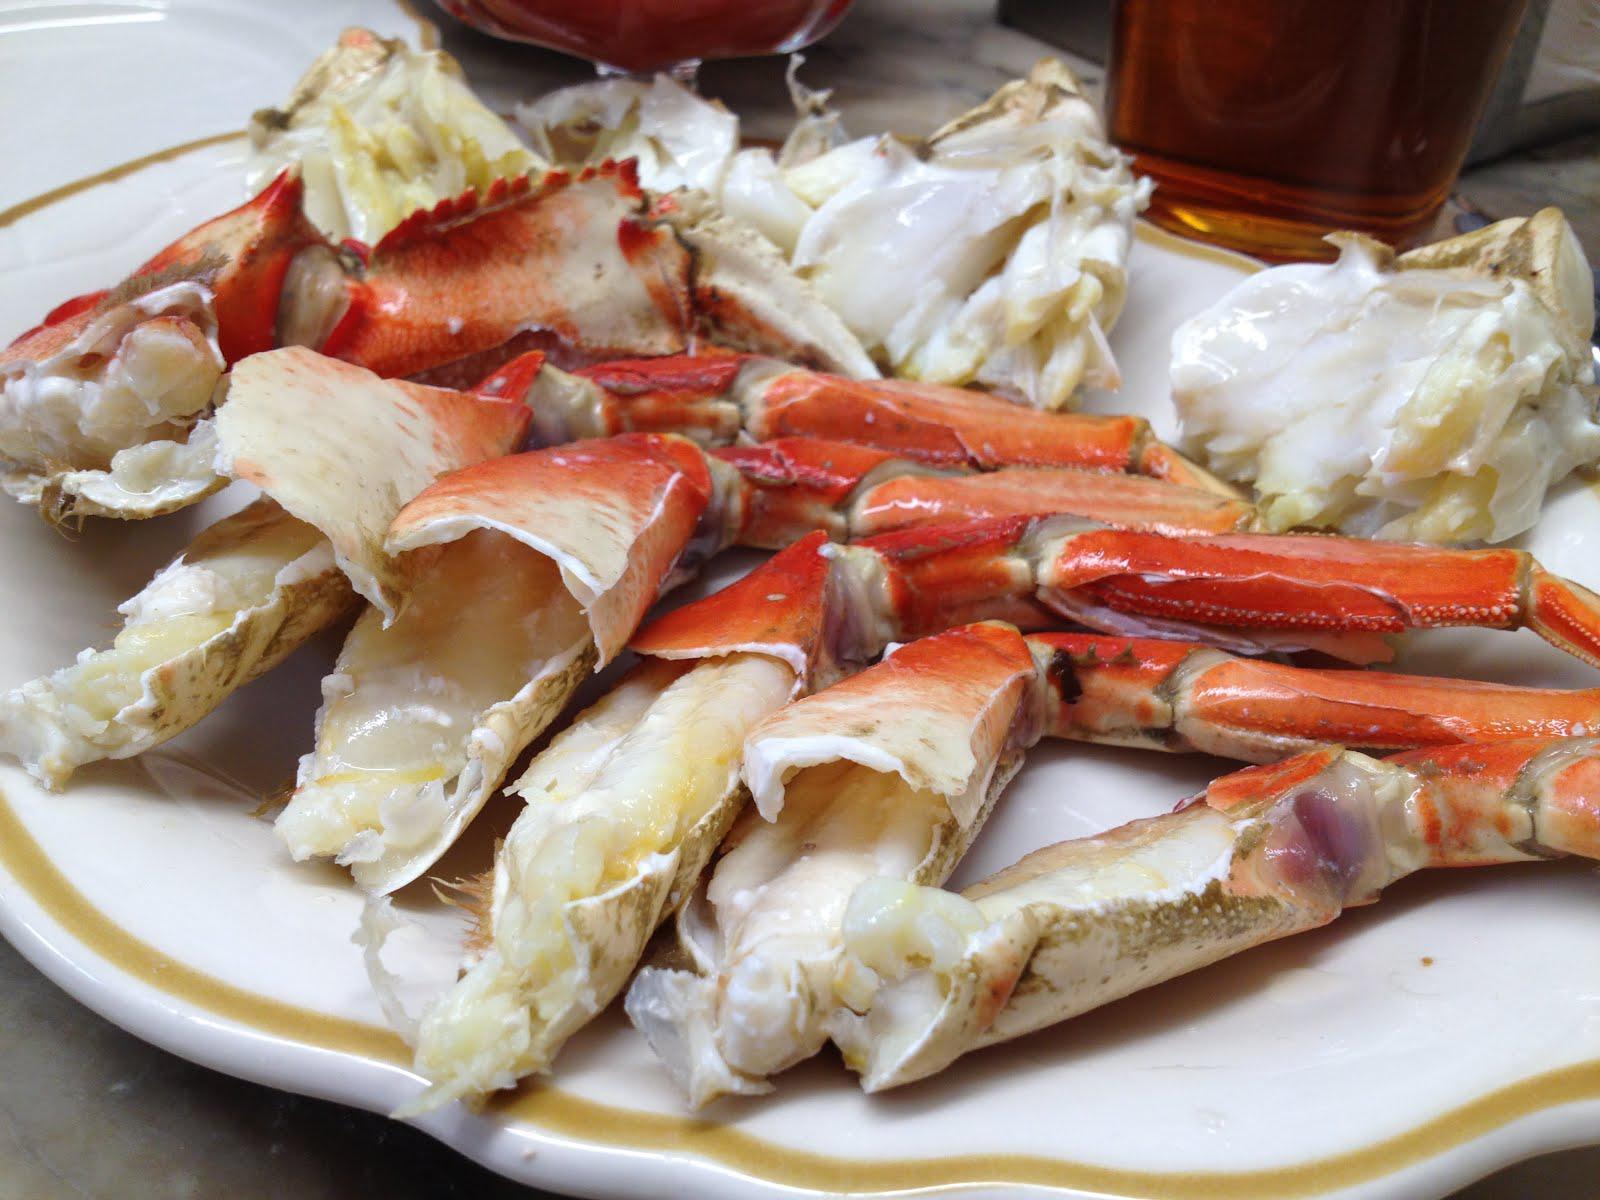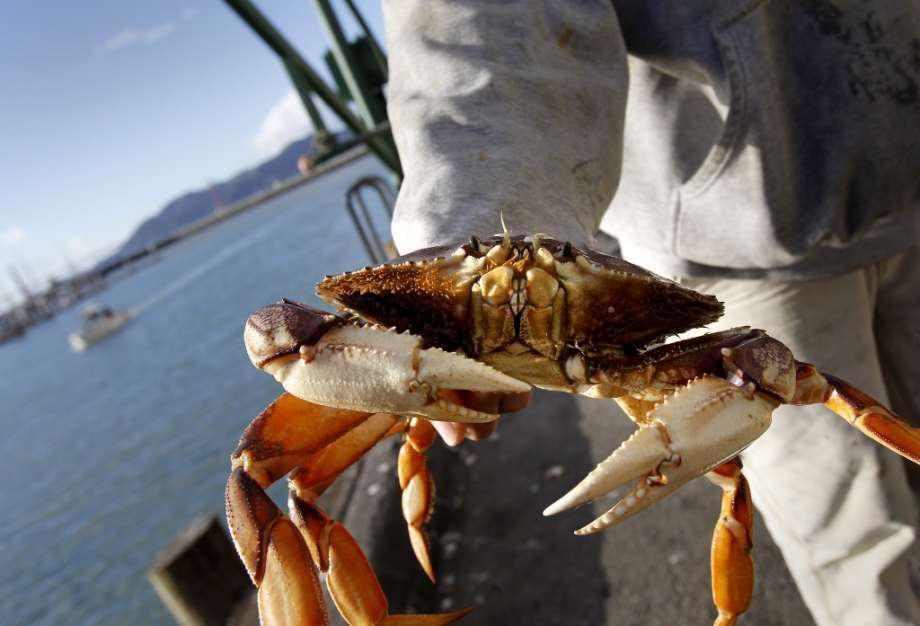The first image is the image on the left, the second image is the image on the right. Considering the images on both sides, is "A hand is holding up a crab with its face and front claws turned toward the camera in the right image." valid? Answer yes or no. Yes. The first image is the image on the left, the second image is the image on the right. Analyze the images presented: Is the assertion "There are two small white top bottles on either side of two red crabs." valid? Answer yes or no. No. 